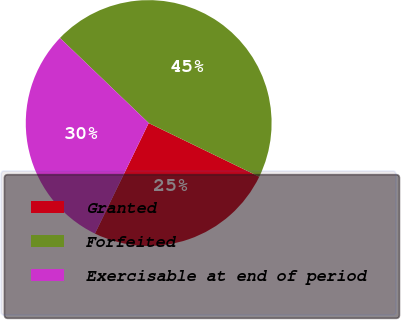Convert chart to OTSL. <chart><loc_0><loc_0><loc_500><loc_500><pie_chart><fcel>Granted<fcel>Forfeited<fcel>Exercisable at end of period<nl><fcel>25.01%<fcel>45.03%<fcel>29.96%<nl></chart> 